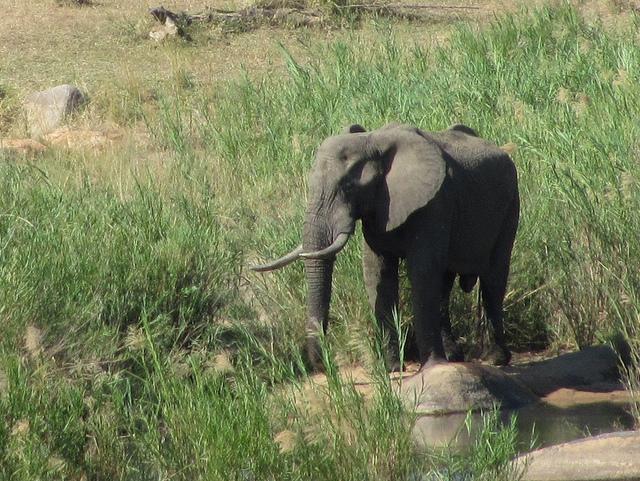How many tusks are visible in the image?
Give a very brief answer. 2. 